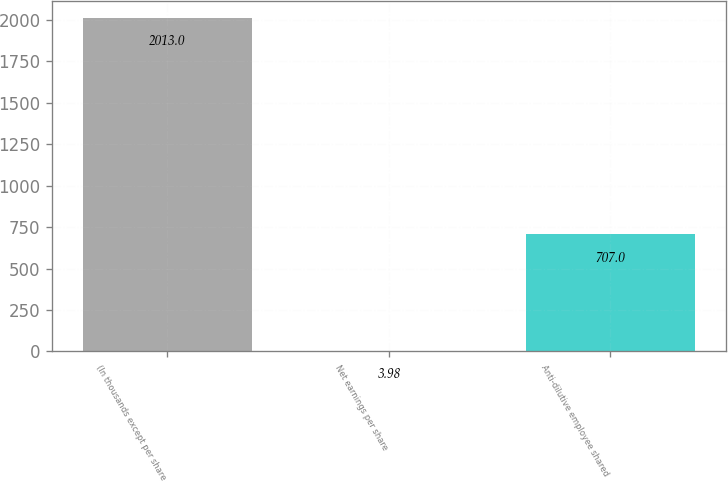Convert chart to OTSL. <chart><loc_0><loc_0><loc_500><loc_500><bar_chart><fcel>(In thousands except per share<fcel>Net earnings per share<fcel>Anti-dilutive employee shared<nl><fcel>2013<fcel>3.98<fcel>707<nl></chart> 